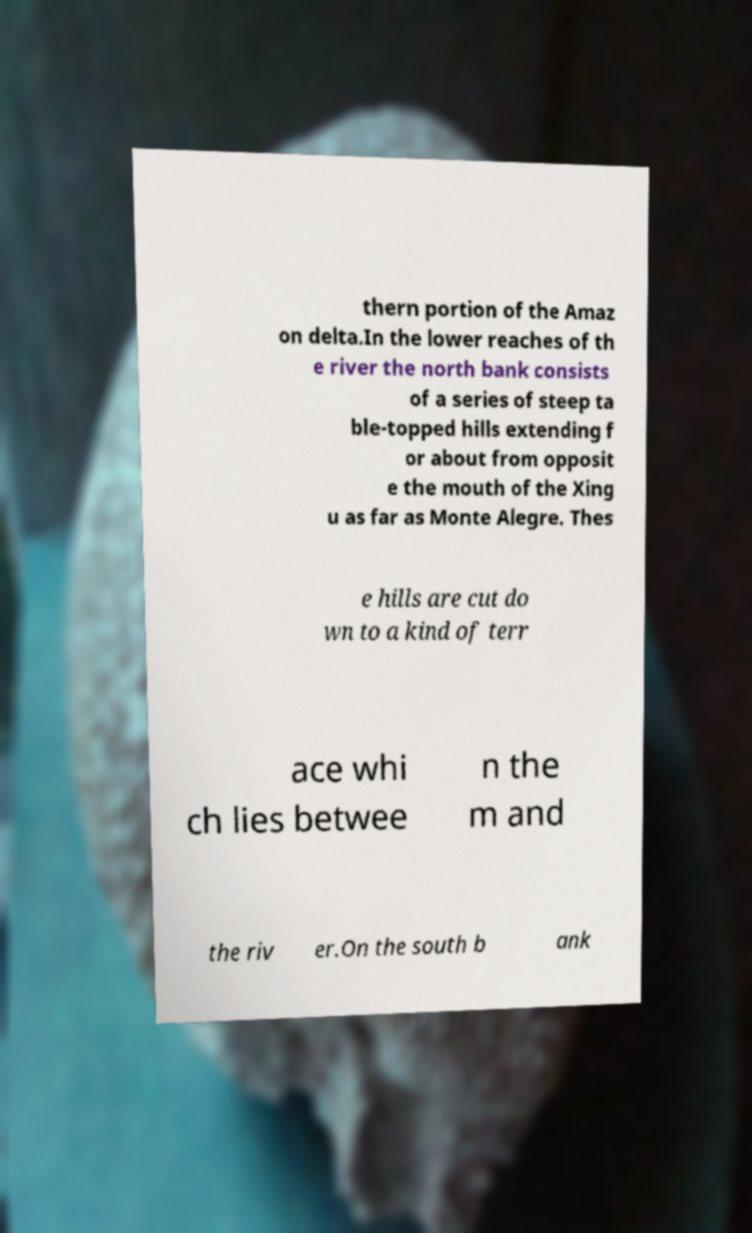Could you extract and type out the text from this image? thern portion of the Amaz on delta.In the lower reaches of th e river the north bank consists of a series of steep ta ble-topped hills extending f or about from opposit e the mouth of the Xing u as far as Monte Alegre. Thes e hills are cut do wn to a kind of terr ace whi ch lies betwee n the m and the riv er.On the south b ank 